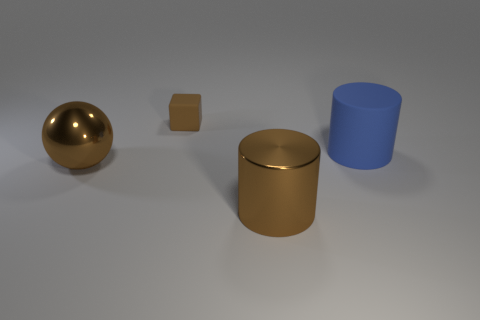Subtract all blue cylinders. How many cylinders are left? 1 Add 2 big gray cylinders. How many objects exist? 6 Subtract all red cylinders. Subtract all yellow blocks. How many cylinders are left? 2 Subtract all purple spheres. How many blue cylinders are left? 1 Subtract all large shiny spheres. Subtract all large green metal cylinders. How many objects are left? 3 Add 2 brown matte blocks. How many brown matte blocks are left? 3 Add 4 big brown things. How many big brown things exist? 6 Subtract 0 purple cylinders. How many objects are left? 4 Subtract all spheres. How many objects are left? 3 